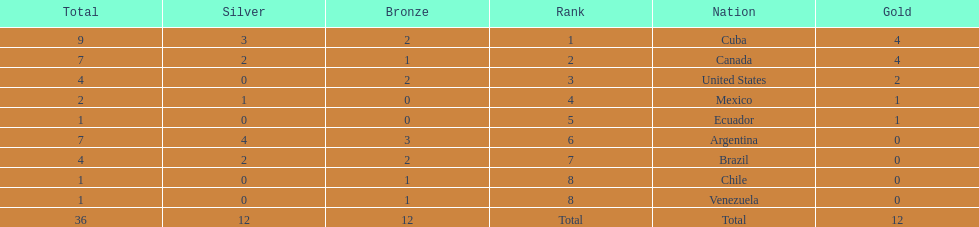Which country won the largest haul of bronze medals? Argentina. 